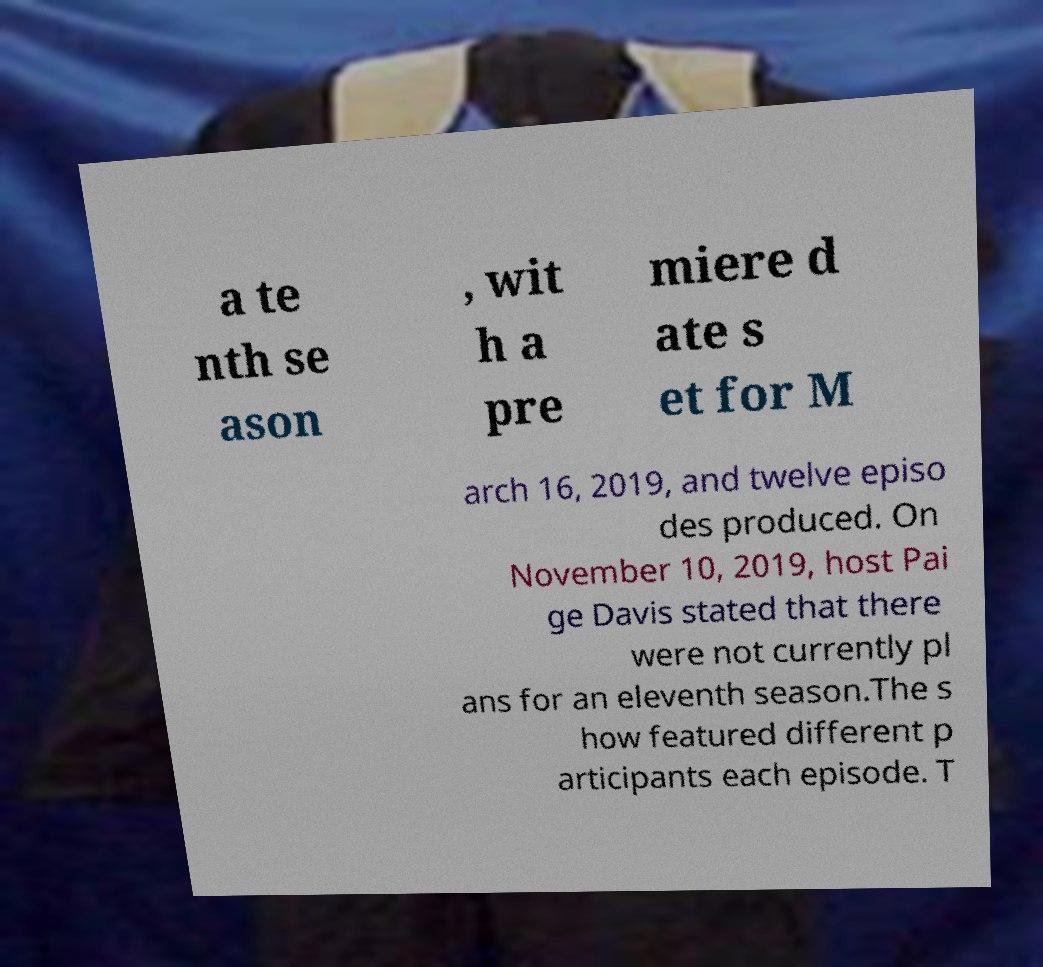Please read and relay the text visible in this image. What does it say? a te nth se ason , wit h a pre miere d ate s et for M arch 16, 2019, and twelve episo des produced. On November 10, 2019, host Pai ge Davis stated that there were not currently pl ans for an eleventh season.The s how featured different p articipants each episode. T 